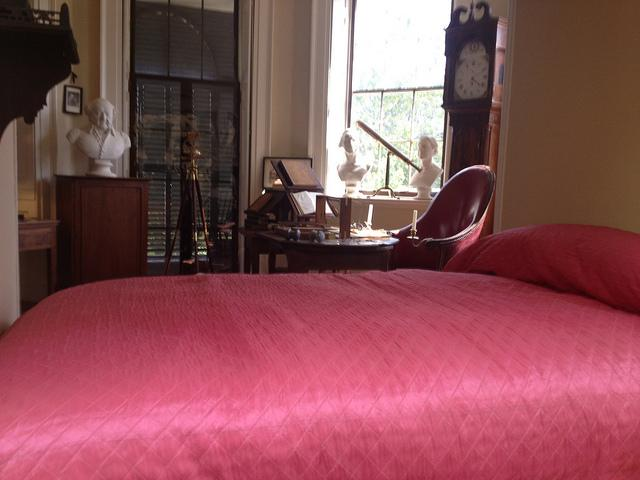What category of clocks does the clock by the window belong to?

Choices:
A) digital
B) tactile
C) longcase
D) cuckoo longcase 